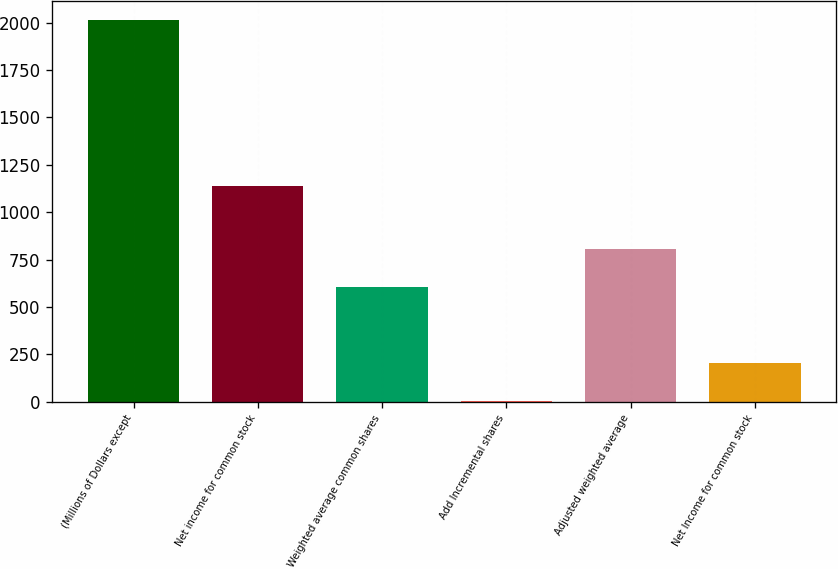Convert chart. <chart><loc_0><loc_0><loc_500><loc_500><bar_chart><fcel>(Millions of Dollars except<fcel>Net income for common stock<fcel>Weighted average common shares<fcel>Add Incremental shares<fcel>Adjusted weighted average<fcel>Net Income for common stock<nl><fcel>2012<fcel>1138<fcel>604.72<fcel>1.6<fcel>805.76<fcel>202.64<nl></chart> 